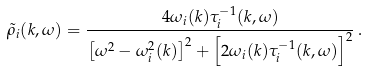Convert formula to latex. <formula><loc_0><loc_0><loc_500><loc_500>\tilde { \rho } _ { i } ( { k } , \omega ) = \frac { 4 \omega _ { i } ( { k } ) \tau _ { i } ^ { - 1 } ( { k } , \omega ) } { \left [ \omega ^ { 2 } - \omega _ { i } ^ { 2 } ( { k } ) \right ] ^ { 2 } + \left [ 2 \omega _ { i } ( { k } ) \tau _ { i } ^ { - 1 } ( { k } , \omega ) \right ] ^ { 2 } } \, .</formula> 